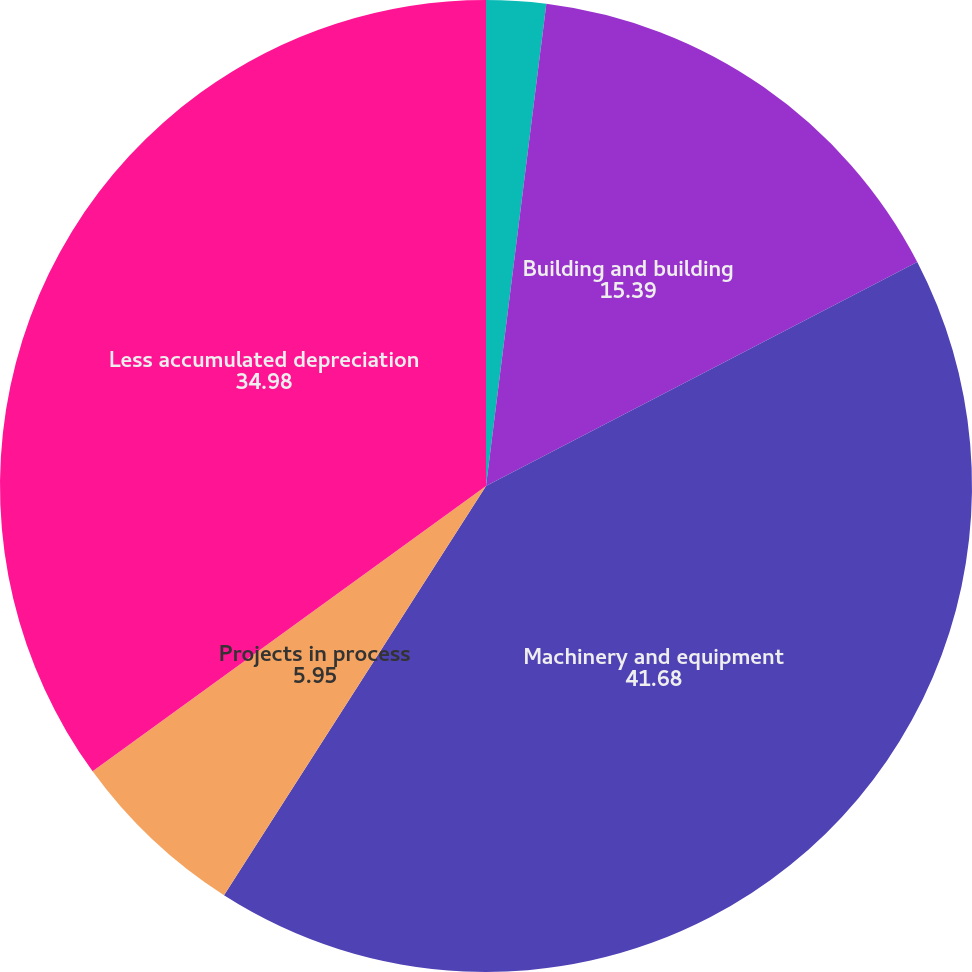Convert chart. <chart><loc_0><loc_0><loc_500><loc_500><pie_chart><fcel>Land<fcel>Building and building<fcel>Machinery and equipment<fcel>Projects in process<fcel>Less accumulated depreciation<nl><fcel>1.98%<fcel>15.39%<fcel>41.68%<fcel>5.95%<fcel>34.98%<nl></chart> 